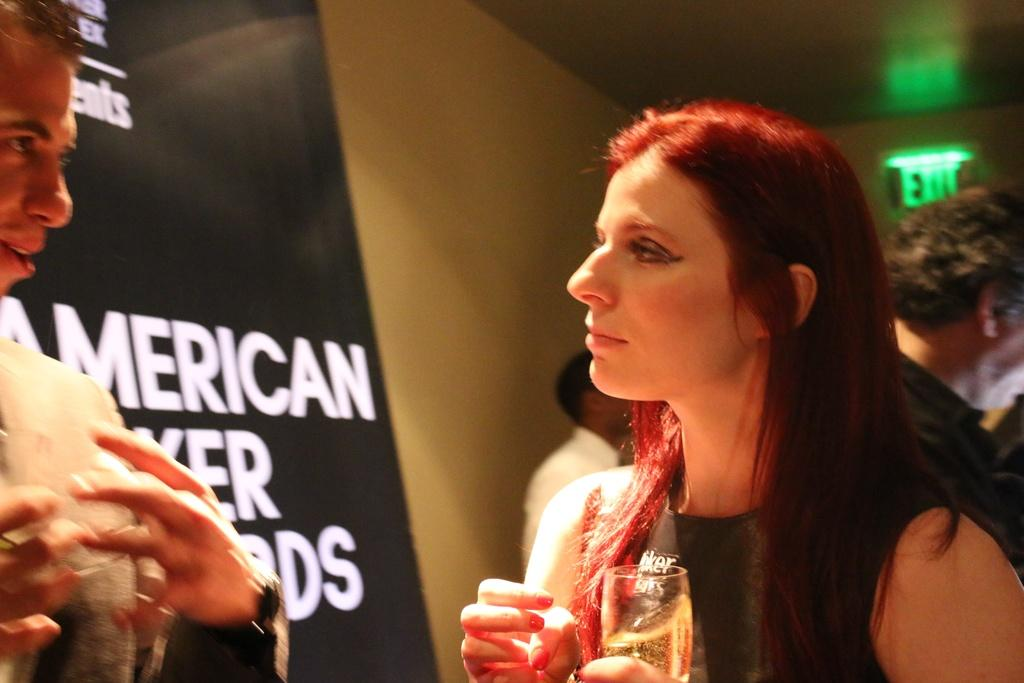Who is the main subject in the image? There is a lady in the image. What is the lady wearing? The lady is wearing a black dress. What is the lady holding in the image? The lady is holding a glass. Who else is present in the image? There is a man in the image. How is the man positioned in relation to the lady? The man is in front of the lady. What type of toys can be seen in the image? There are no toys present in the image. What message of peace is being conveyed in the image? There is no message of peace explicitly conveyed in the image; it simply shows a lady and a man with the lady holding a glass. 